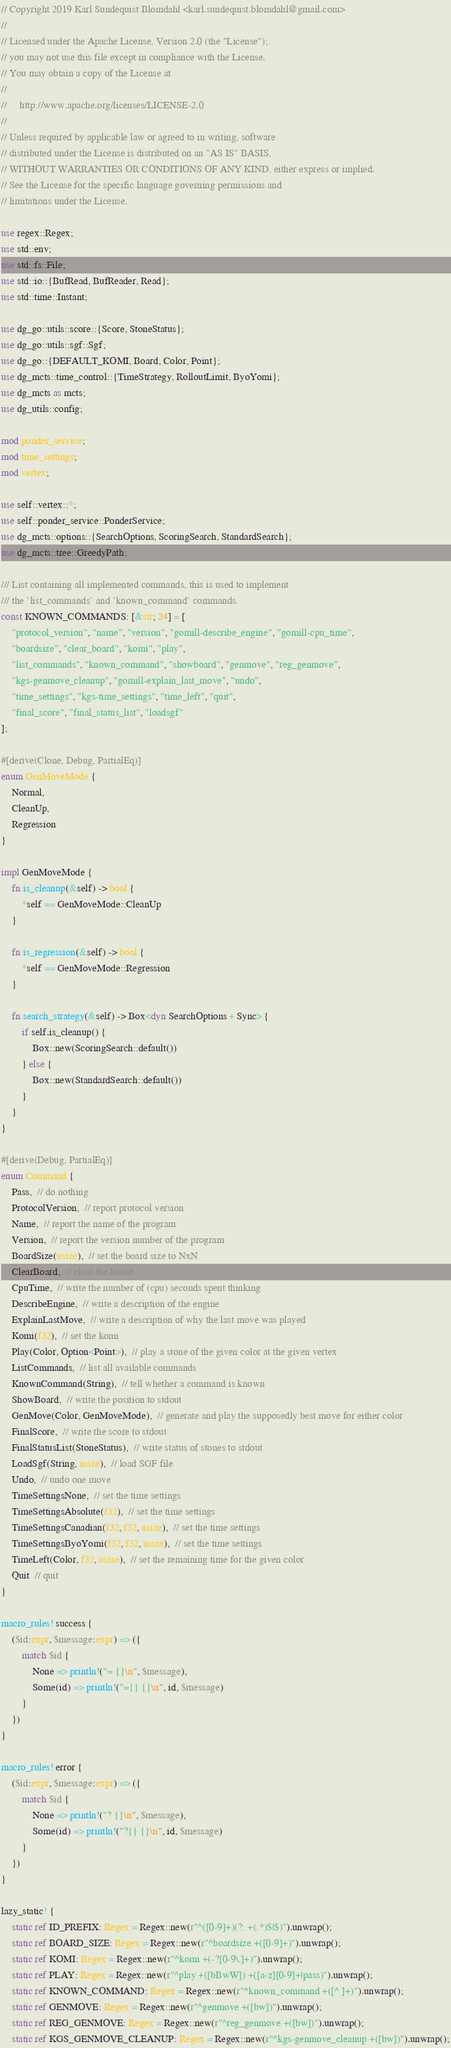Convert code to text. <code><loc_0><loc_0><loc_500><loc_500><_Rust_>// Copyright 2019 Karl Sundequist Blomdahl <karl.sundequist.blomdahl@gmail.com>
//
// Licensed under the Apache License, Version 2.0 (the "License");
// you may not use this file except in compliance with the License.
// You may obtain a copy of the License at
//
//     http://www.apache.org/licenses/LICENSE-2.0
//
// Unless required by applicable law or agreed to in writing, software
// distributed under the License is distributed on an "AS IS" BASIS,
// WITHOUT WARRANTIES OR CONDITIONS OF ANY KIND, either express or implied.
// See the License for the specific language governing permissions and
// limitations under the License.

use regex::Regex;
use std::env;
use std::fs::File;
use std::io::{BufRead, BufReader, Read};
use std::time::Instant;

use dg_go::utils::score::{Score, StoneStatus};
use dg_go::utils::sgf::Sgf;
use dg_go::{DEFAULT_KOMI, Board, Color, Point};
use dg_mcts::time_control::{TimeStrategy, RolloutLimit, ByoYomi};
use dg_mcts as mcts;
use dg_utils::config;

mod ponder_service;
mod time_settings;
mod vertex;

use self::vertex::*;
use self::ponder_service::PonderService;
use dg_mcts::options::{SearchOptions, ScoringSearch, StandardSearch};
use dg_mcts::tree::GreedyPath;

/// List containing all implemented commands, this is used to implement
/// the `list_commands` and `known_command` commands.
const KNOWN_COMMANDS: [&str; 24] = [
    "protocol_version", "name", "version", "gomill-describe_engine", "gomill-cpu_time",
    "boardsize", "clear_board", "komi", "play",
    "list_commands", "known_command", "showboard", "genmove", "reg_genmove",
    "kgs-genmove_cleanup", "gomill-explain_last_move", "undo",
    "time_settings", "kgs-time_settings", "time_left", "quit",
    "final_score", "final_status_list", "loadsgf"
];

#[derive(Clone, Debug, PartialEq)]
enum GenMoveMode {
    Normal,
    CleanUp,
    Regression
}

impl GenMoveMode {
    fn is_cleanup(&self) -> bool {
        *self == GenMoveMode::CleanUp
    }

    fn is_regression(&self) -> bool {
        *self == GenMoveMode::Regression
    }

    fn search_strategy(&self) -> Box<dyn SearchOptions + Sync> {
        if self.is_cleanup() {
            Box::new(ScoringSearch::default())
        } else {
            Box::new(StandardSearch::default())
        }
    }
}

#[derive(Debug, PartialEq)]
enum Command {
    Pass,  // do nothing
    ProtocolVersion,  // report protocol version
    Name,  // report the name of the program
    Version,  // report the version number of the program
    BoardSize(usize),  // set the board size to NxN
    ClearBoard,  // clear the board
    CpuTime,  // write the number of (cpu) seconds spent thinking
    DescribeEngine,  // write a description of the engine
    ExplainLastMove,  // write a description of why the last move was played
    Komi(f32),  // set the komi
    Play(Color, Option<Point>),  // play a stone of the given color at the given vertex
    ListCommands,  // list all available commands
    KnownCommand(String),  // tell whether a command is known
    ShowBoard,  // write the position to stdout
    GenMove(Color, GenMoveMode),  // generate and play the supposedly best move for either color
    FinalScore,  // write the score to stdout
    FinalStatusList(StoneStatus),  // write status of stones to stdout
    LoadSgf(String, usize),  // load SGF file
    Undo,  // undo one move
    TimeSettingsNone,  // set the time settings
    TimeSettingsAbsolute(f32),  // set the time settings
    TimeSettingsCanadian(f32, f32, usize),  // set the time settings
    TimeSettingsByoYomi(f32, f32, usize),  // set the time settings
    TimeLeft(Color, f32, usize),  // set the remaining time for the given color
    Quit  // quit
}

macro_rules! success {
    ($id:expr, $message:expr) => ({
        match $id {
            None => println!("= {}\n", $message),
            Some(id) => println!("={} {}\n", id, $message)
        }
    })
}

macro_rules! error {
    ($id:expr, $message:expr) => ({
        match $id {
            None => println!("? {}\n", $message),
            Some(id) => println!("?{} {}\n", id, $message)
        }
    })
}

lazy_static! {
    static ref ID_PREFIX: Regex = Regex::new(r"^([0-9]+)(?: +(.*)$|$)").unwrap();
    static ref BOARD_SIZE: Regex = Regex::new(r"^boardsize +([0-9]+)").unwrap();
    static ref KOMI: Regex = Regex::new(r"^komi +(-?[0-9\.]+)").unwrap();
    static ref PLAY: Regex = Regex::new(r"^play +([bBwW]) +([a-z][0-9]+|pass)").unwrap();
    static ref KNOWN_COMMAND: Regex = Regex::new(r"^known_command +([^ ]+)").unwrap();
    static ref GENMOVE: Regex = Regex::new(r"^genmove +([bw])").unwrap();
    static ref REG_GENMOVE: Regex = Regex::new(r"^reg_genmove +([bw])").unwrap();
    static ref KGS_GENMOVE_CLEANUP: Regex = Regex::new(r"^kgs-genmove_cleanup +([bw])").unwrap();</code> 